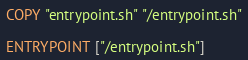<code> <loc_0><loc_0><loc_500><loc_500><_Dockerfile_>COPY "entrypoint.sh" "/entrypoint.sh"

ENTRYPOINT ["/entrypoint.sh"]
</code> 